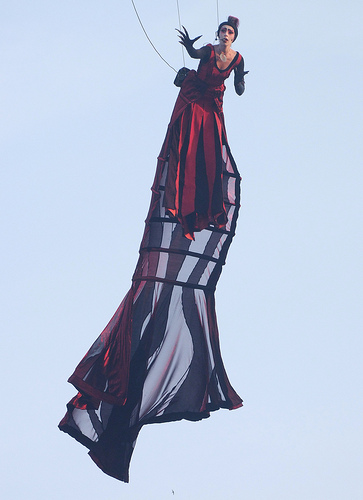<image>
Is the woman to the right of the rope? Yes. From this viewpoint, the woman is positioned to the right side relative to the rope. 